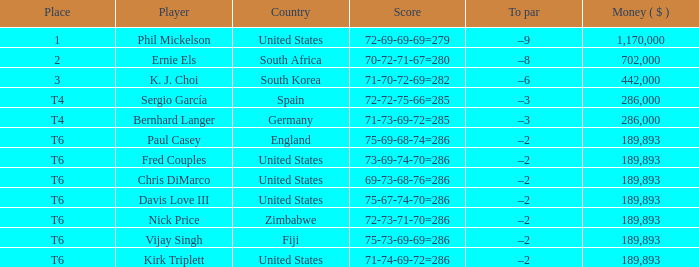What is the monetary amount ($) when the position is t6, and participant is chris dimarco? 189893.0. 